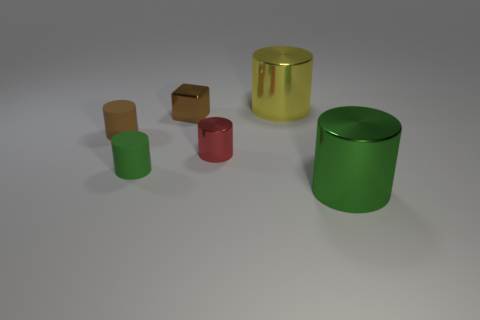Subtract all tiny red metallic cylinders. How many cylinders are left? 4 Subtract all blue blocks. How many green cylinders are left? 2 Add 2 brown spheres. How many objects exist? 8 Subtract all brown cylinders. How many cylinders are left? 4 Subtract all cubes. How many objects are left? 5 Subtract 3 cylinders. How many cylinders are left? 2 Add 5 red cylinders. How many red cylinders exist? 6 Subtract 0 gray cylinders. How many objects are left? 6 Subtract all red cubes. Subtract all purple balls. How many cubes are left? 1 Subtract all brown metal objects. Subtract all large green shiny cylinders. How many objects are left? 4 